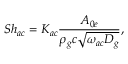<formula> <loc_0><loc_0><loc_500><loc_500>S h _ { a c } = K _ { a c } \frac { A _ { 0 e } } { \rho _ { g } c \sqrt { \omega _ { a c } D _ { g } } } ,</formula> 